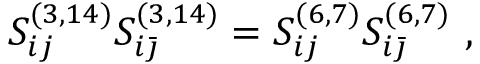<formula> <loc_0><loc_0><loc_500><loc_500>S _ { i j } ^ { ( 3 , 1 4 ) } S _ { i { \bar { \jmath } } } ^ { ( 3 , 1 4 ) } = S _ { i j } ^ { ( 6 , 7 ) } S _ { i { \bar { \jmath } } } ^ { ( 6 , 7 ) } \ ,</formula> 